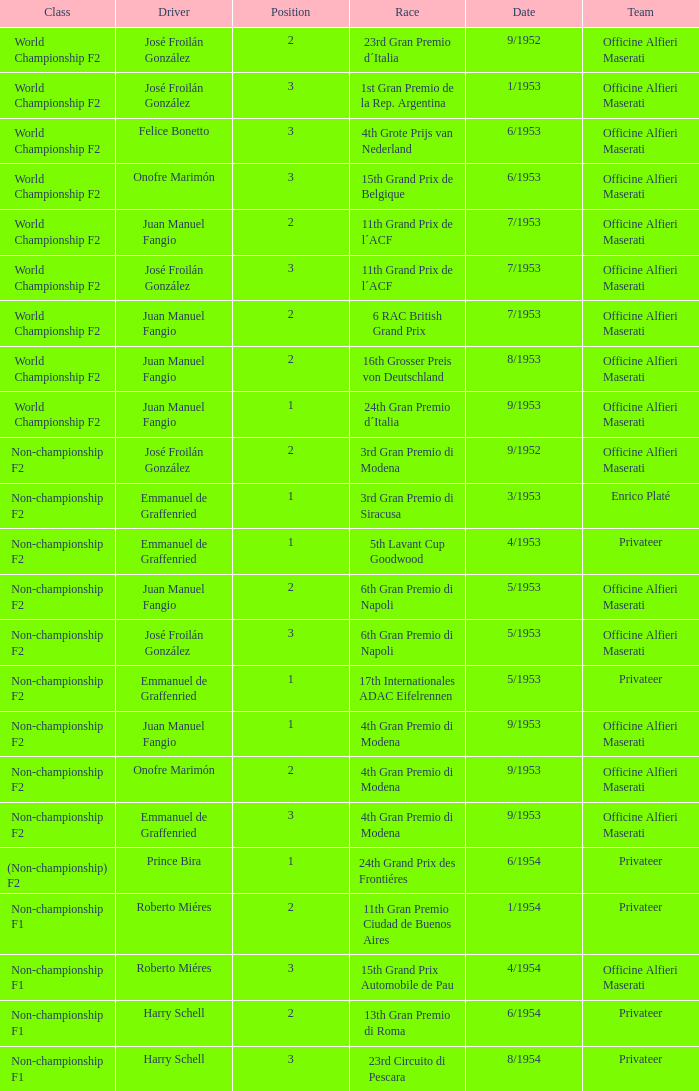What driver has a team of officine alfieri maserati and belongs to the class of non-championship f2 and has a position of 2, as well as a date of 9/1952? José Froilán González. 